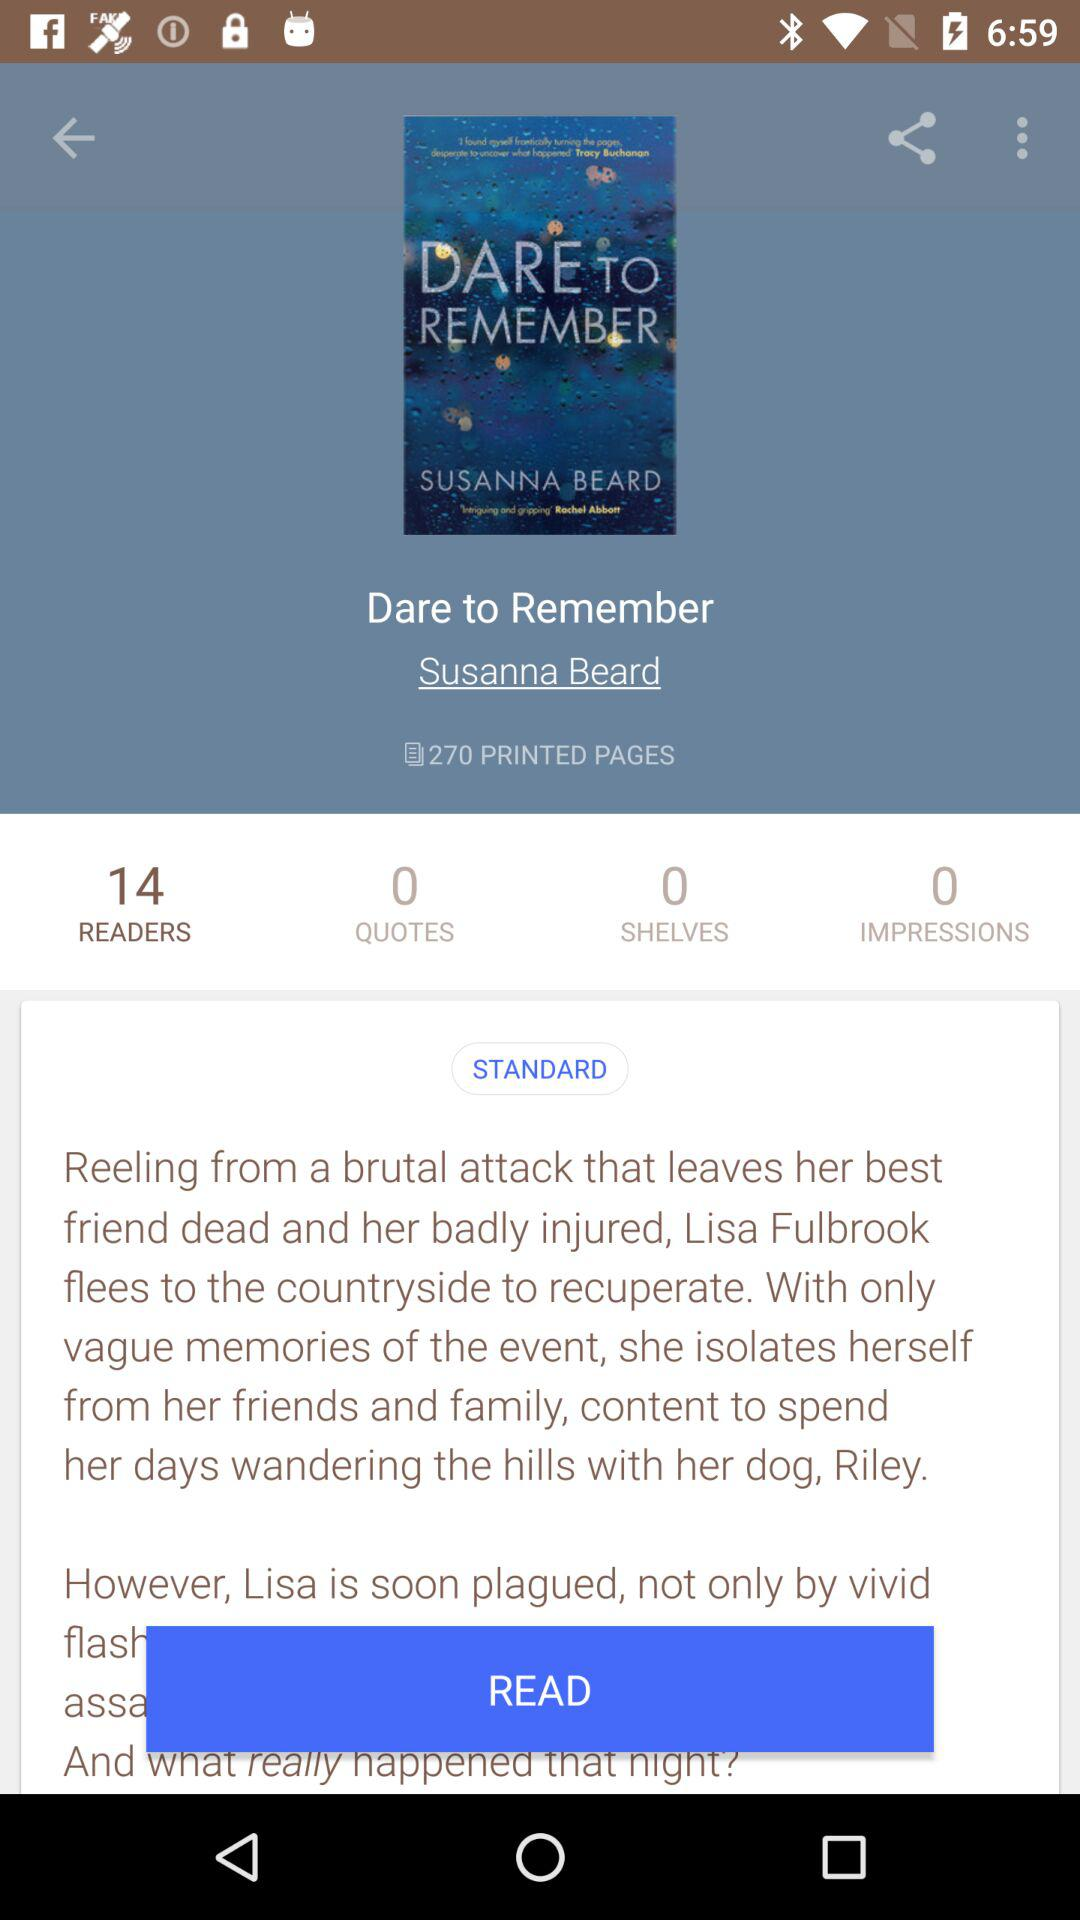How many quotes are there for the book? There are 0 quotes for the book. 